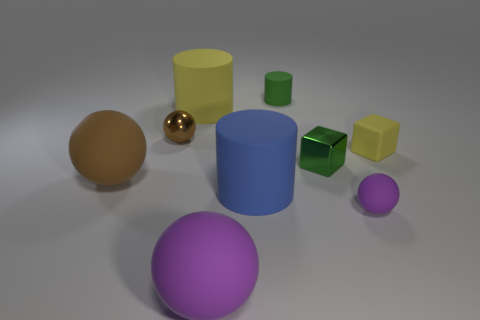Subtract all small brown balls. How many balls are left? 3 Subtract 2 blocks. How many blocks are left? 0 Subtract all red blocks. How many brown spheres are left? 2 Subtract all spheres. How many objects are left? 5 Subtract all yellow blocks. How many blocks are left? 1 Subtract all red cylinders. Subtract all gray cubes. How many cylinders are left? 3 Subtract all metallic balls. Subtract all tiny matte blocks. How many objects are left? 7 Add 6 tiny green rubber cylinders. How many tiny green rubber cylinders are left? 7 Add 7 tiny blue cylinders. How many tiny blue cylinders exist? 7 Subtract 0 yellow balls. How many objects are left? 9 